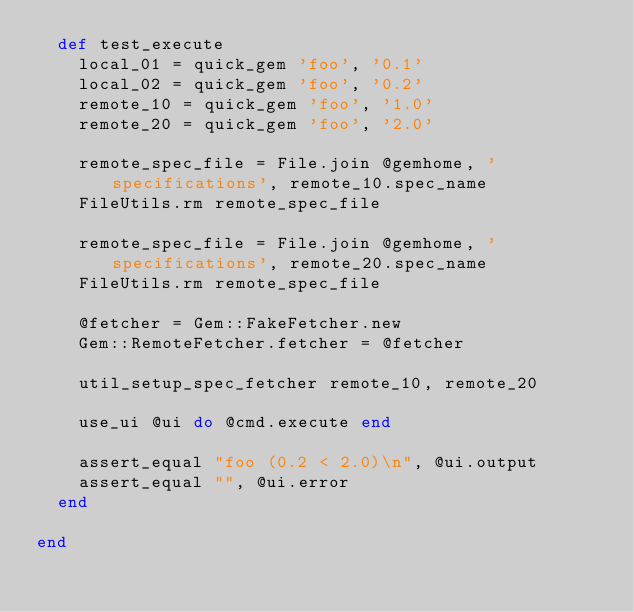<code> <loc_0><loc_0><loc_500><loc_500><_Ruby_>  def test_execute
    local_01 = quick_gem 'foo', '0.1'
    local_02 = quick_gem 'foo', '0.2'
    remote_10 = quick_gem 'foo', '1.0'
    remote_20 = quick_gem 'foo', '2.0'

    remote_spec_file = File.join @gemhome, 'specifications', remote_10.spec_name
    FileUtils.rm remote_spec_file

    remote_spec_file = File.join @gemhome, 'specifications', remote_20.spec_name
    FileUtils.rm remote_spec_file

    @fetcher = Gem::FakeFetcher.new
    Gem::RemoteFetcher.fetcher = @fetcher

    util_setup_spec_fetcher remote_10, remote_20

    use_ui @ui do @cmd.execute end

    assert_equal "foo (0.2 < 2.0)\n", @ui.output
    assert_equal "", @ui.error
  end

end

</code> 